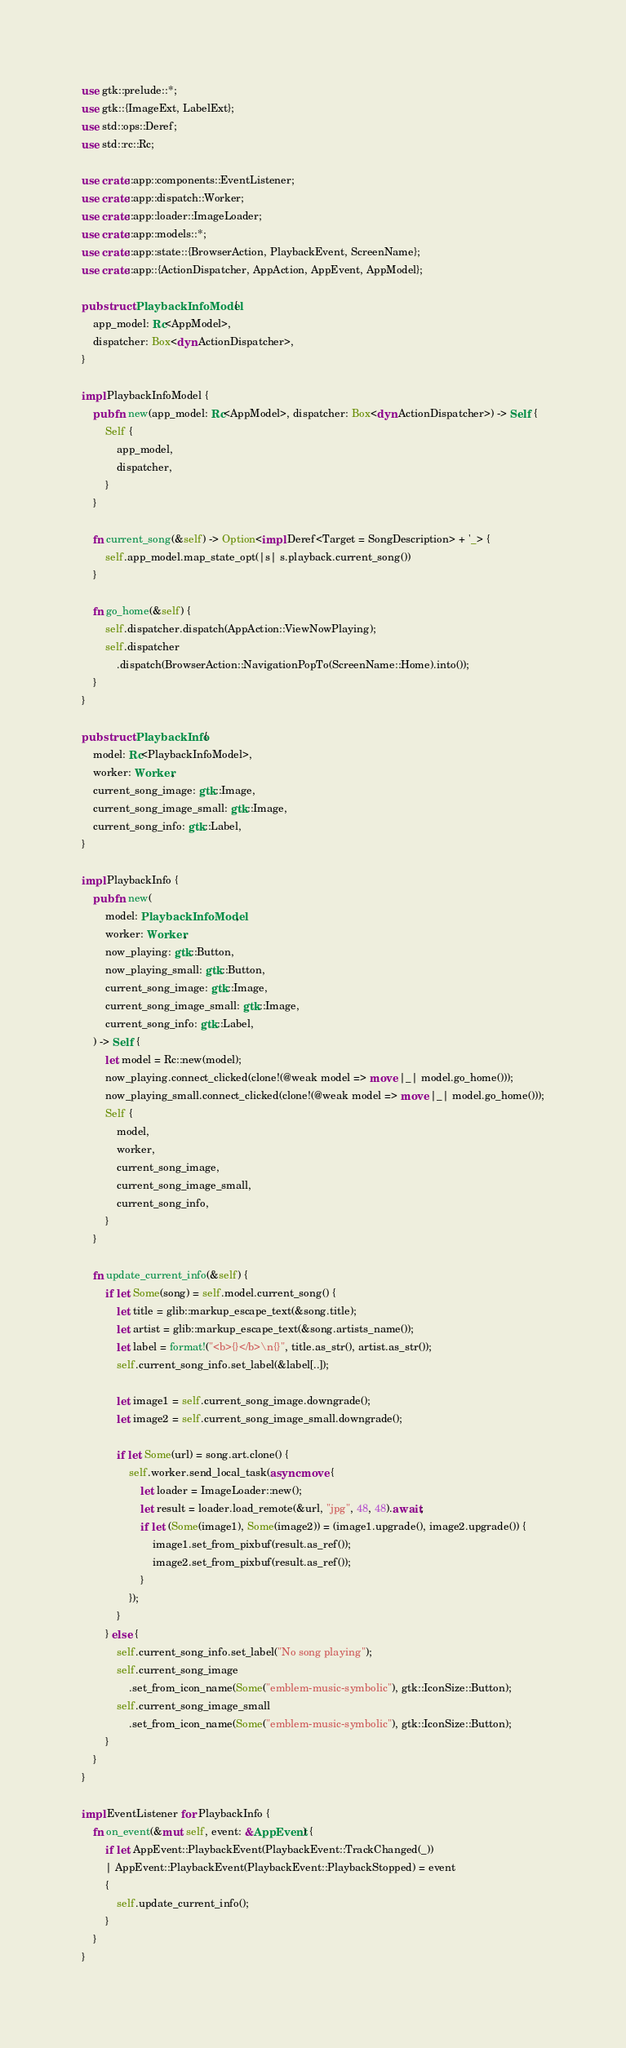<code> <loc_0><loc_0><loc_500><loc_500><_Rust_>use gtk::prelude::*;
use gtk::{ImageExt, LabelExt};
use std::ops::Deref;
use std::rc::Rc;

use crate::app::components::EventListener;
use crate::app::dispatch::Worker;
use crate::app::loader::ImageLoader;
use crate::app::models::*;
use crate::app::state::{BrowserAction, PlaybackEvent, ScreenName};
use crate::app::{ActionDispatcher, AppAction, AppEvent, AppModel};

pub struct PlaybackInfoModel {
    app_model: Rc<AppModel>,
    dispatcher: Box<dyn ActionDispatcher>,
}

impl PlaybackInfoModel {
    pub fn new(app_model: Rc<AppModel>, dispatcher: Box<dyn ActionDispatcher>) -> Self {
        Self {
            app_model,
            dispatcher,
        }
    }

    fn current_song(&self) -> Option<impl Deref<Target = SongDescription> + '_> {
        self.app_model.map_state_opt(|s| s.playback.current_song())
    }

    fn go_home(&self) {
        self.dispatcher.dispatch(AppAction::ViewNowPlaying);
        self.dispatcher
            .dispatch(BrowserAction::NavigationPopTo(ScreenName::Home).into());
    }
}

pub struct PlaybackInfo {
    model: Rc<PlaybackInfoModel>,
    worker: Worker,
    current_song_image: gtk::Image,
    current_song_image_small: gtk::Image,
    current_song_info: gtk::Label,
}

impl PlaybackInfo {
    pub fn new(
        model: PlaybackInfoModel,
        worker: Worker,
        now_playing: gtk::Button,
        now_playing_small: gtk::Button,
        current_song_image: gtk::Image,
        current_song_image_small: gtk::Image,
        current_song_info: gtk::Label,
    ) -> Self {
        let model = Rc::new(model);
        now_playing.connect_clicked(clone!(@weak model => move |_| model.go_home()));
        now_playing_small.connect_clicked(clone!(@weak model => move |_| model.go_home()));
        Self {
            model,
            worker,
            current_song_image,
            current_song_image_small,
            current_song_info,
        }
    }

    fn update_current_info(&self) {
        if let Some(song) = self.model.current_song() {
            let title = glib::markup_escape_text(&song.title);
            let artist = glib::markup_escape_text(&song.artists_name());
            let label = format!("<b>{}</b>\n{}", title.as_str(), artist.as_str());
            self.current_song_info.set_label(&label[..]);

            let image1 = self.current_song_image.downgrade();
            let image2 = self.current_song_image_small.downgrade();

            if let Some(url) = song.art.clone() {
                self.worker.send_local_task(async move {
                    let loader = ImageLoader::new();
                    let result = loader.load_remote(&url, "jpg", 48, 48).await;
                    if let (Some(image1), Some(image2)) = (image1.upgrade(), image2.upgrade()) {
                        image1.set_from_pixbuf(result.as_ref());
                        image2.set_from_pixbuf(result.as_ref());
                    }
                });
            }
        } else {
            self.current_song_info.set_label("No song playing");
            self.current_song_image
                .set_from_icon_name(Some("emblem-music-symbolic"), gtk::IconSize::Button);
            self.current_song_image_small
                .set_from_icon_name(Some("emblem-music-symbolic"), gtk::IconSize::Button);
        }
    }
}

impl EventListener for PlaybackInfo {
    fn on_event(&mut self, event: &AppEvent) {
        if let AppEvent::PlaybackEvent(PlaybackEvent::TrackChanged(_))
        | AppEvent::PlaybackEvent(PlaybackEvent::PlaybackStopped) = event
        {
            self.update_current_info();
        }
    }
}
</code> 